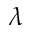Convert formula to latex. <formula><loc_0><loc_0><loc_500><loc_500>\lambda</formula> 